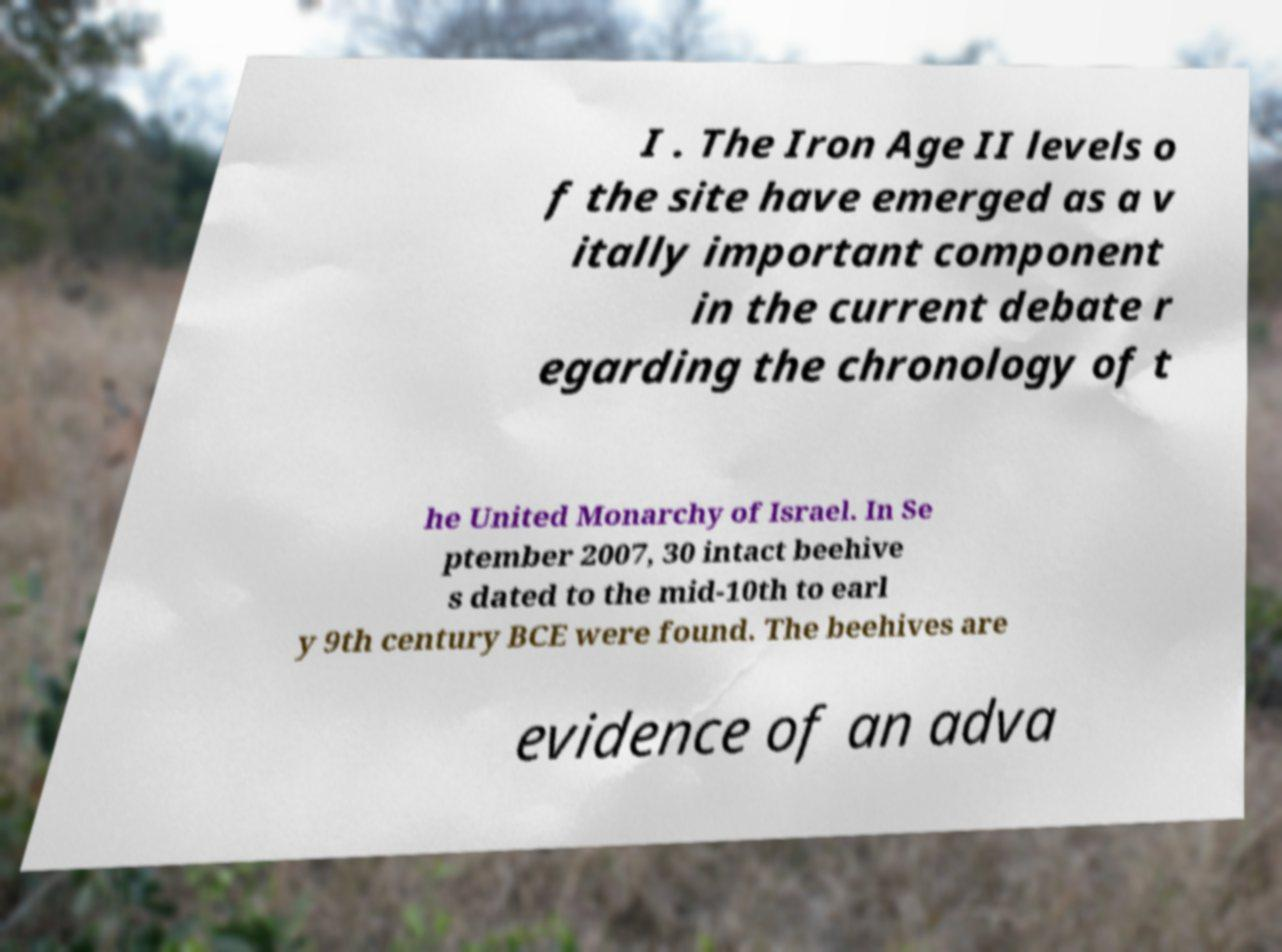Please identify and transcribe the text found in this image. I . The Iron Age II levels o f the site have emerged as a v itally important component in the current debate r egarding the chronology of t he United Monarchy of Israel. In Se ptember 2007, 30 intact beehive s dated to the mid-10th to earl y 9th century BCE were found. The beehives are evidence of an adva 